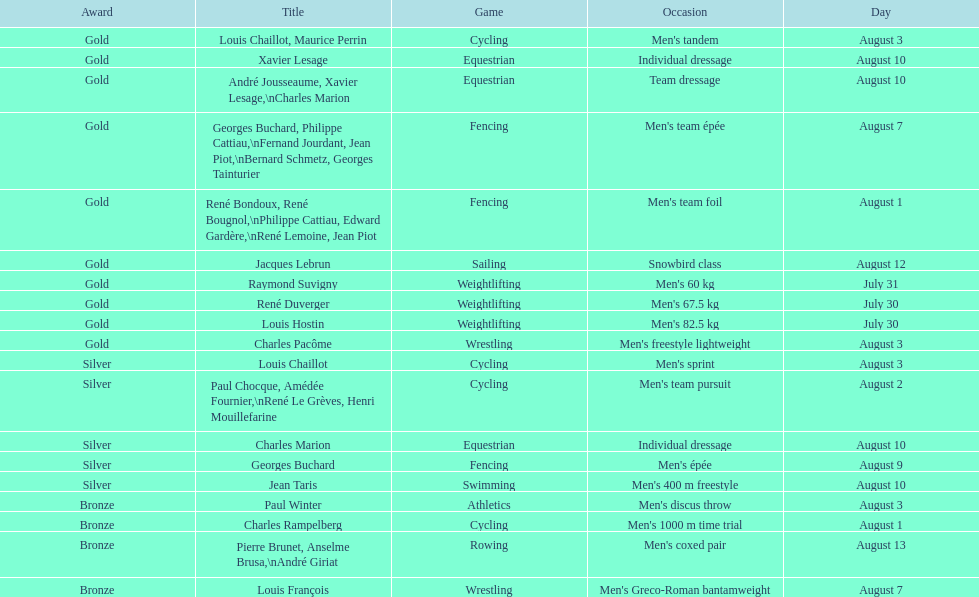Would you be able to parse every entry in this table? {'header': ['Award', 'Title', 'Game', 'Occasion', 'Day'], 'rows': [['Gold', 'Louis Chaillot, Maurice Perrin', 'Cycling', "Men's tandem", 'August 3'], ['Gold', 'Xavier Lesage', 'Equestrian', 'Individual dressage', 'August 10'], ['Gold', 'André Jousseaume, Xavier Lesage,\\nCharles Marion', 'Equestrian', 'Team dressage', 'August 10'], ['Gold', 'Georges Buchard, Philippe Cattiau,\\nFernand Jourdant, Jean Piot,\\nBernard Schmetz, Georges Tainturier', 'Fencing', "Men's team épée", 'August 7'], ['Gold', 'René Bondoux, René Bougnol,\\nPhilippe Cattiau, Edward Gardère,\\nRené Lemoine, Jean Piot', 'Fencing', "Men's team foil", 'August 1'], ['Gold', 'Jacques Lebrun', 'Sailing', 'Snowbird class', 'August 12'], ['Gold', 'Raymond Suvigny', 'Weightlifting', "Men's 60 kg", 'July 31'], ['Gold', 'René Duverger', 'Weightlifting', "Men's 67.5 kg", 'July 30'], ['Gold', 'Louis Hostin', 'Weightlifting', "Men's 82.5 kg", 'July 30'], ['Gold', 'Charles Pacôme', 'Wrestling', "Men's freestyle lightweight", 'August 3'], ['Silver', 'Louis Chaillot', 'Cycling', "Men's sprint", 'August 3'], ['Silver', 'Paul Chocque, Amédée Fournier,\\nRené Le Grèves, Henri Mouillefarine', 'Cycling', "Men's team pursuit", 'August 2'], ['Silver', 'Charles Marion', 'Equestrian', 'Individual dressage', 'August 10'], ['Silver', 'Georges Buchard', 'Fencing', "Men's épée", 'August 9'], ['Silver', 'Jean Taris', 'Swimming', "Men's 400 m freestyle", 'August 10'], ['Bronze', 'Paul Winter', 'Athletics', "Men's discus throw", 'August 3'], ['Bronze', 'Charles Rampelberg', 'Cycling', "Men's 1000 m time trial", 'August 1'], ['Bronze', 'Pierre Brunet, Anselme Brusa,\\nAndré Giriat', 'Rowing', "Men's coxed pair", 'August 13'], ['Bronze', 'Louis François', 'Wrestling', "Men's Greco-Roman bantamweight", 'August 7']]} What is next date that is listed after august 7th? August 1. 